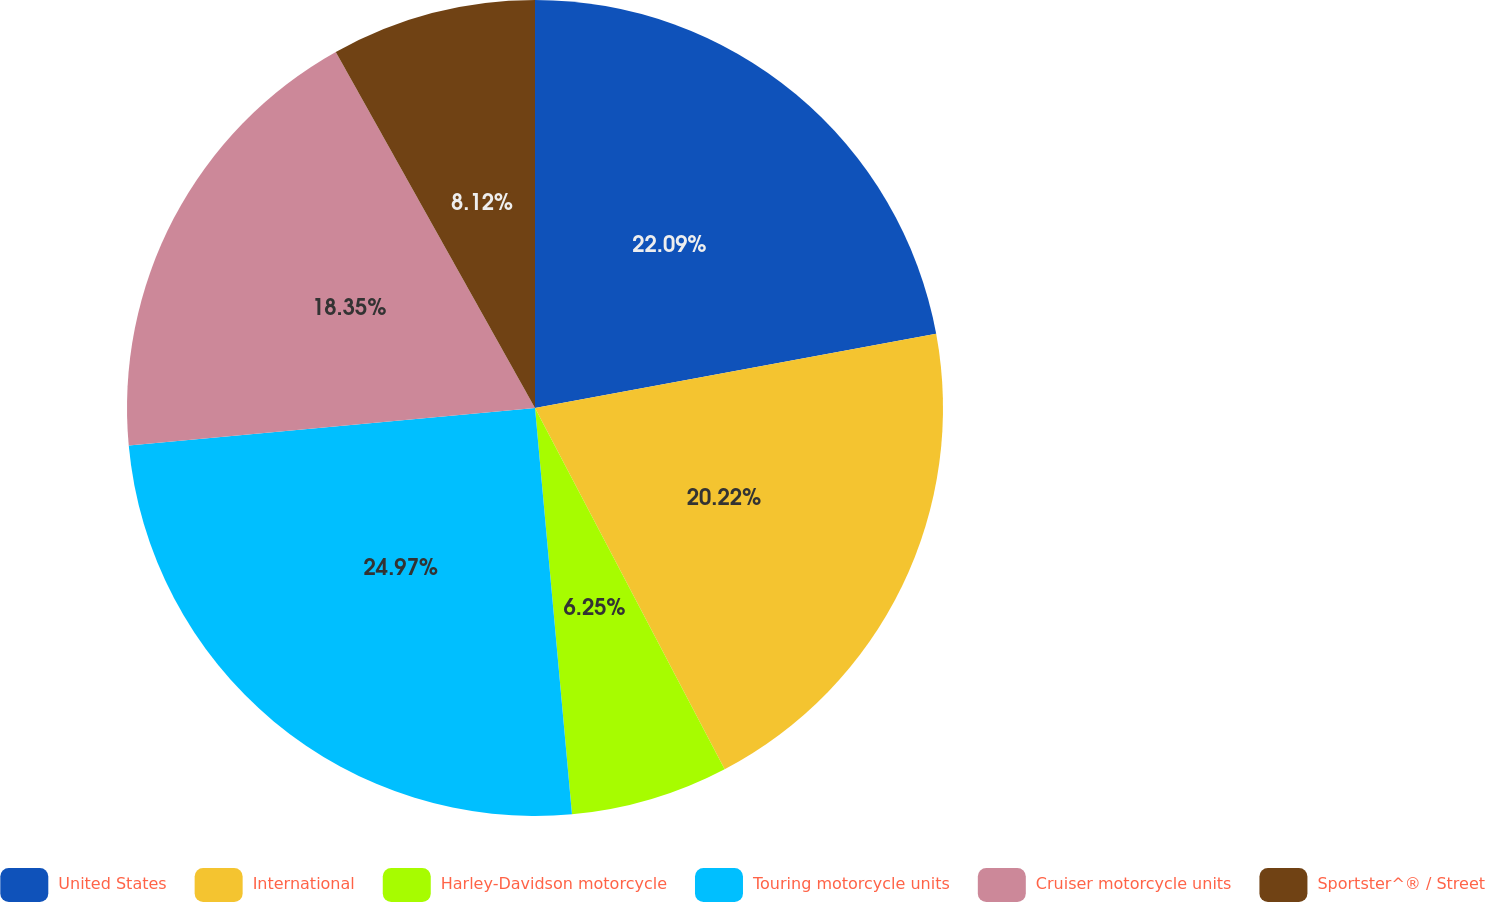Convert chart. <chart><loc_0><loc_0><loc_500><loc_500><pie_chart><fcel>United States<fcel>International<fcel>Harley-Davidson motorcycle<fcel>Touring motorcycle units<fcel>Cruiser motorcycle units<fcel>Sportster^® / Street<nl><fcel>22.09%<fcel>20.22%<fcel>6.25%<fcel>24.98%<fcel>18.35%<fcel>8.12%<nl></chart> 